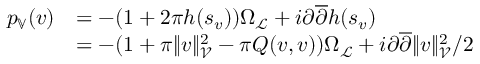Convert formula to latex. <formula><loc_0><loc_0><loc_500><loc_500>\begin{array} { r l } { p _ { \mathbb { V } } ( v ) } & { = - ( 1 + 2 \pi h ( s _ { v } ) ) \Omega _ { \mathcal { L } } + i \partial \overline { \partial } h ( s _ { v } ) } \\ & { = - ( 1 + \pi \| v \| _ { \mathcal { V } } ^ { 2 } - \pi Q ( v , v ) ) \Omega _ { \mathcal { L } } + i \partial \overline { \partial } \| v \| _ { \mathcal { V } } ^ { 2 } / 2 } \end{array}</formula> 